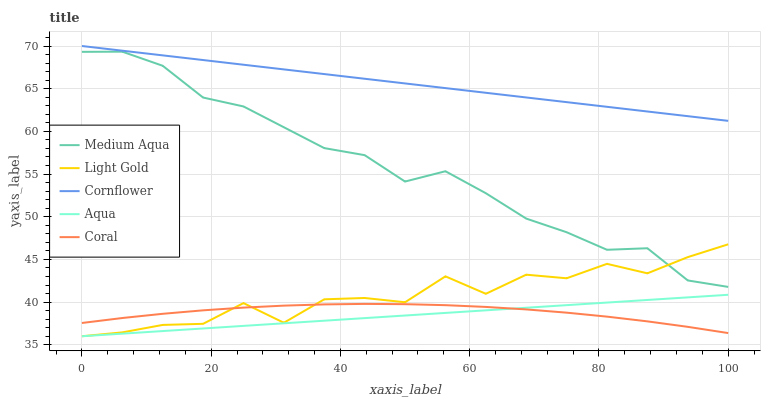Does Aqua have the minimum area under the curve?
Answer yes or no. Yes. Does Cornflower have the maximum area under the curve?
Answer yes or no. Yes. Does Light Gold have the minimum area under the curve?
Answer yes or no. No. Does Light Gold have the maximum area under the curve?
Answer yes or no. No. Is Cornflower the smoothest?
Answer yes or no. Yes. Is Light Gold the roughest?
Answer yes or no. Yes. Is Coral the smoothest?
Answer yes or no. No. Is Coral the roughest?
Answer yes or no. No. Does Aqua have the lowest value?
Answer yes or no. Yes. Does Coral have the lowest value?
Answer yes or no. No. Does Cornflower have the highest value?
Answer yes or no. Yes. Does Light Gold have the highest value?
Answer yes or no. No. Is Aqua less than Medium Aqua?
Answer yes or no. Yes. Is Cornflower greater than Coral?
Answer yes or no. Yes. Does Medium Aqua intersect Light Gold?
Answer yes or no. Yes. Is Medium Aqua less than Light Gold?
Answer yes or no. No. Is Medium Aqua greater than Light Gold?
Answer yes or no. No. Does Aqua intersect Medium Aqua?
Answer yes or no. No. 